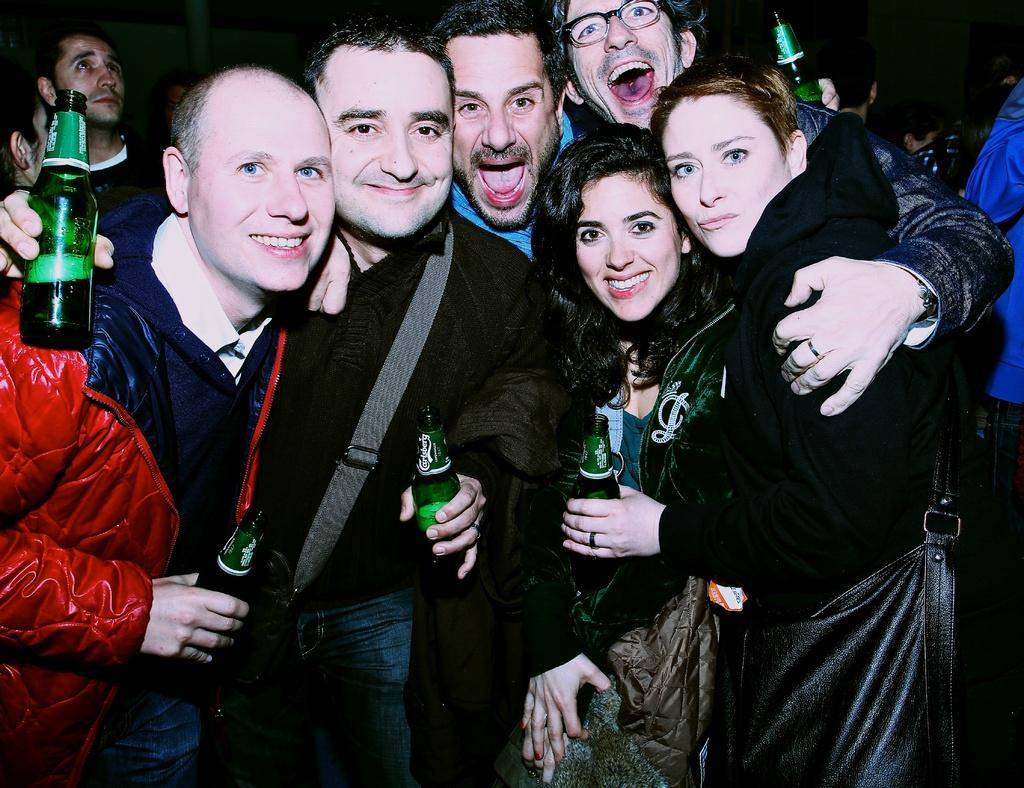What is happening in the image involving a group of people? There is a group of people in the image, and they are standing and smiling. What are the people holding in the image? The people are holding a wine bottle. Can you describe the people in the background of the image? There are more people visible in the background, but their actions and interactions are not clear from the provided facts. What type of prison can be seen in the image? There is no prison present in the image; it features a group of people standing and smiling. How many roots are visible in the image? There are no roots visible in the image. 